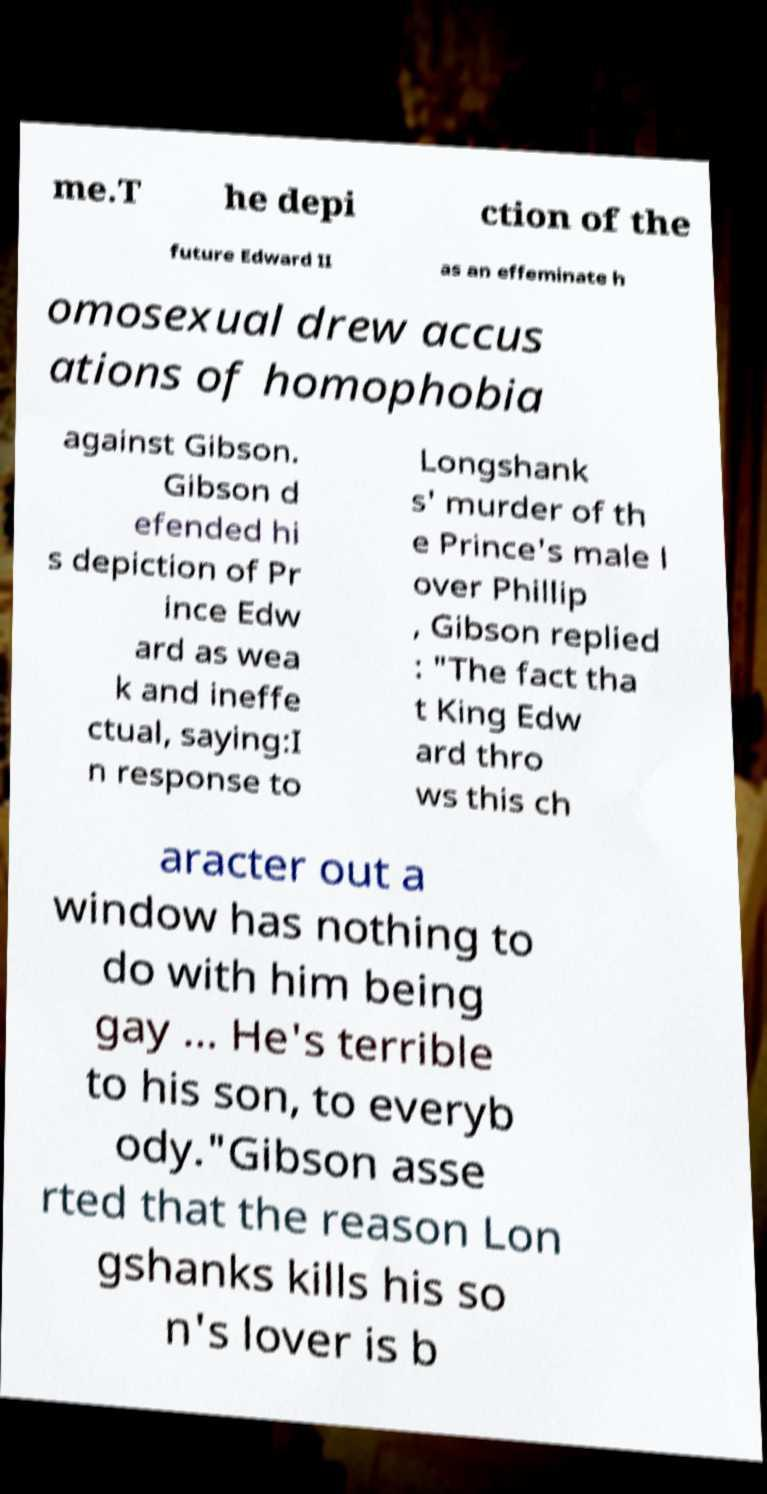I need the written content from this picture converted into text. Can you do that? me.T he depi ction of the future Edward II as an effeminate h omosexual drew accus ations of homophobia against Gibson. Gibson d efended hi s depiction of Pr ince Edw ard as wea k and ineffe ctual, saying:I n response to Longshank s' murder of th e Prince's male l over Phillip , Gibson replied : "The fact tha t King Edw ard thro ws this ch aracter out a window has nothing to do with him being gay ... He's terrible to his son, to everyb ody."Gibson asse rted that the reason Lon gshanks kills his so n's lover is b 